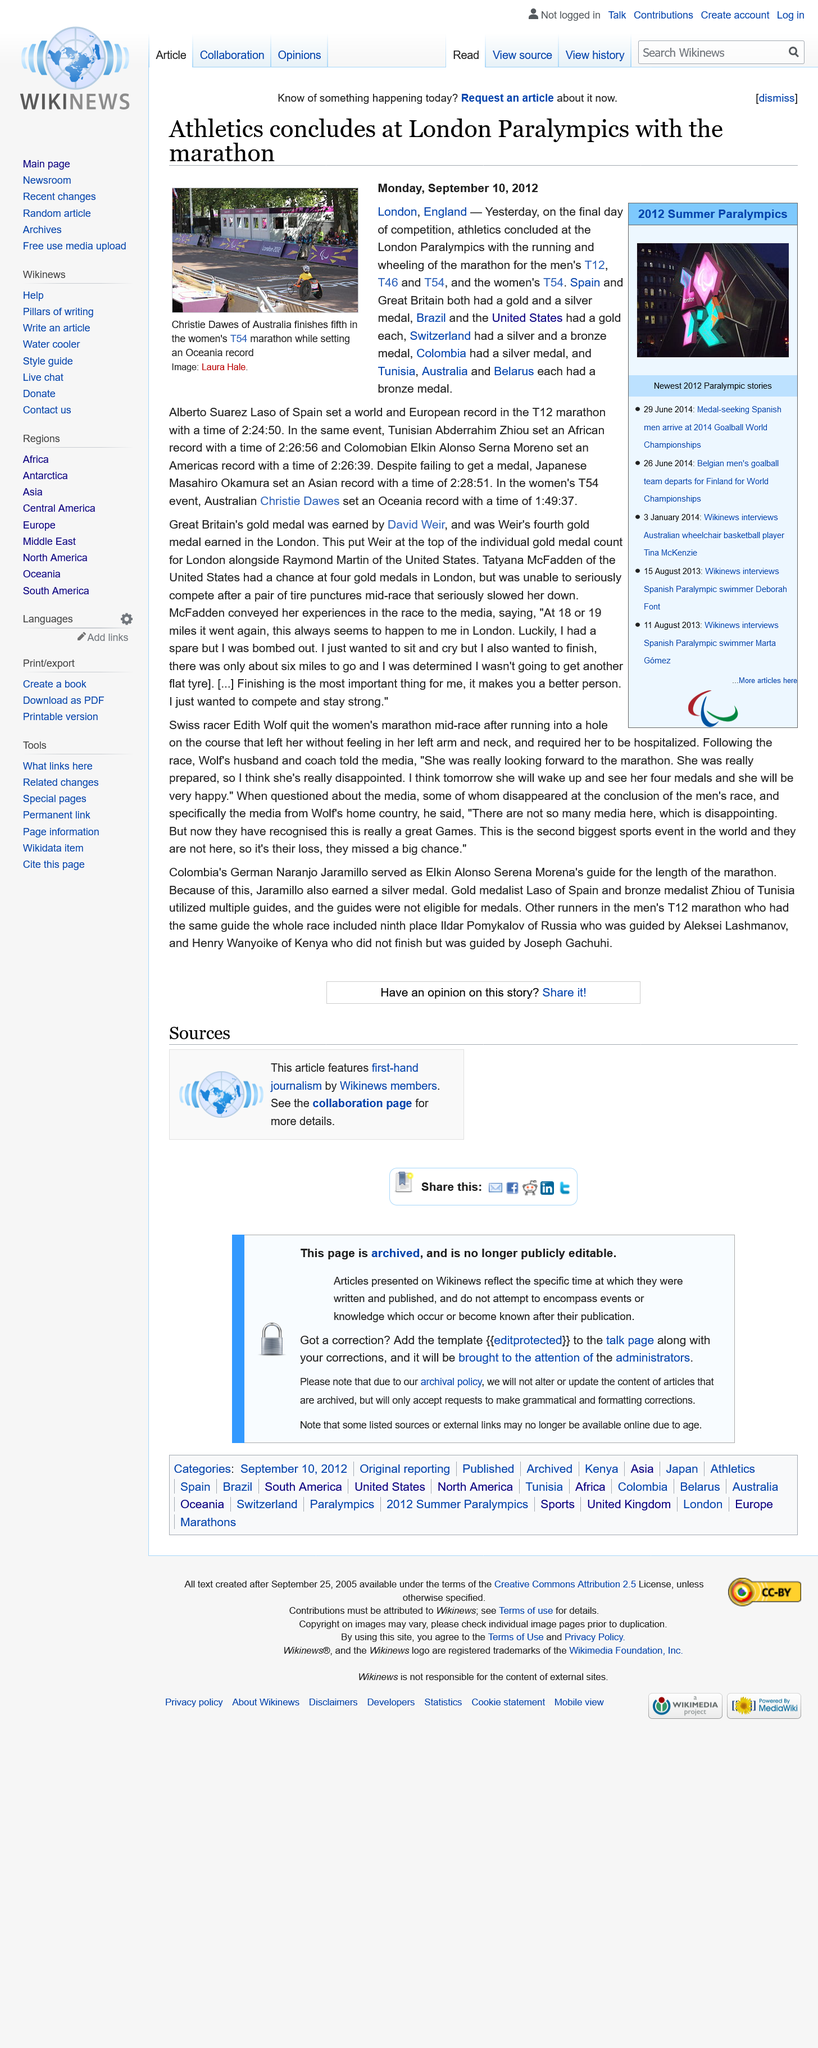Highlight a few significant elements in this photo. On the final day of the London Paralympics, both Spain and Great Britain won a gold and silver medal, respectively. Christie Dawes set an Oceania record in the women's T54 event on the final day of competition in the London Paralympics. Alberto Suarez Laso set a world and European record in the T12 marathon, which is a category for athletes with a visual impairment. This achievement demonstrates his exceptional athletic ability and determination. 